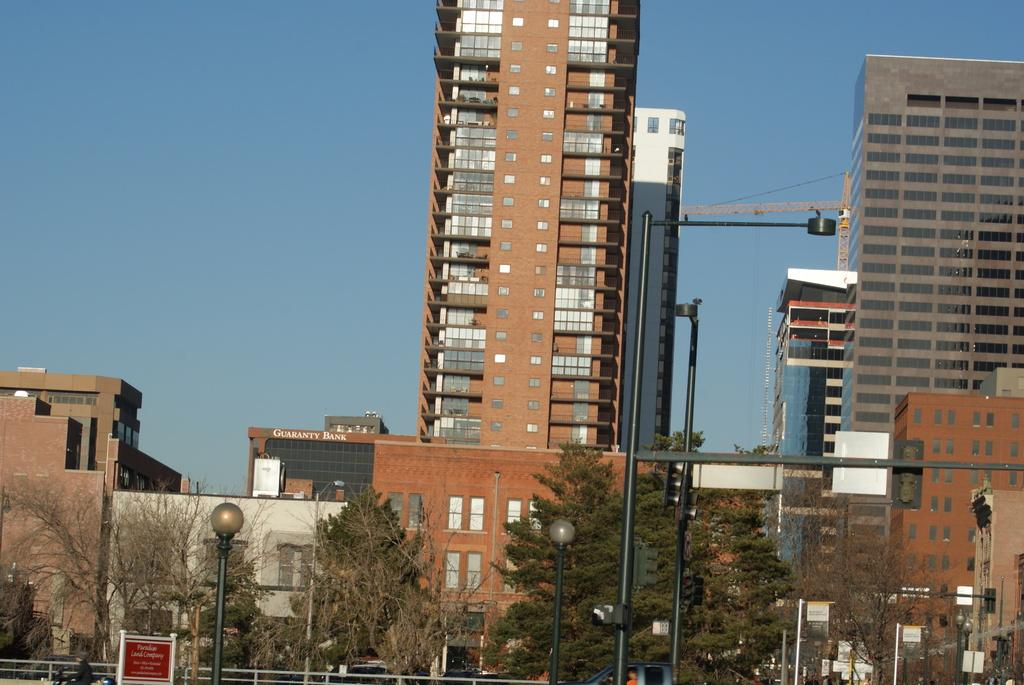What type of structures can be seen in the image? There are buildings in the image. What other natural elements are present in the image? There are trees in the image. What type of infrastructure is visible in the image? Electric poles with lights and traffic signals are present in the image. What objects are used for displaying information in the image? Boards are present in the image. What else can be seen in the image besides the mentioned elements? There are other objects in the image. What is visible in the background of the image? The sky is visible in the background of the image. What type of notebook is being used to write on the angle in the image? There is no notebook or angle present in the image. What is the end result of the construction project in the image? The image does not show a construction project or an end result. 